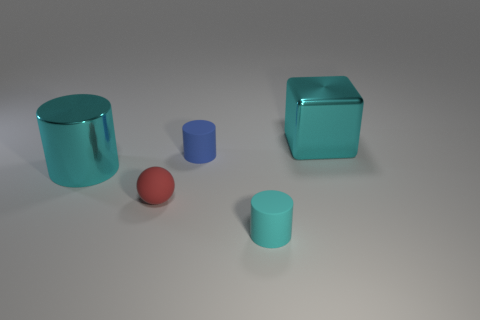Does the scene suggest a particular use or function for these objects? The scene doesn't suggest a specific use or function; it seems to be a simple arrangement of geometric shapes possibly for display or illustrative purposes. If these were real objects, what materials could they be made of? If they were real, their reflective surfaces suggest they might be made of materials like polished metal, glass, or plastic. 